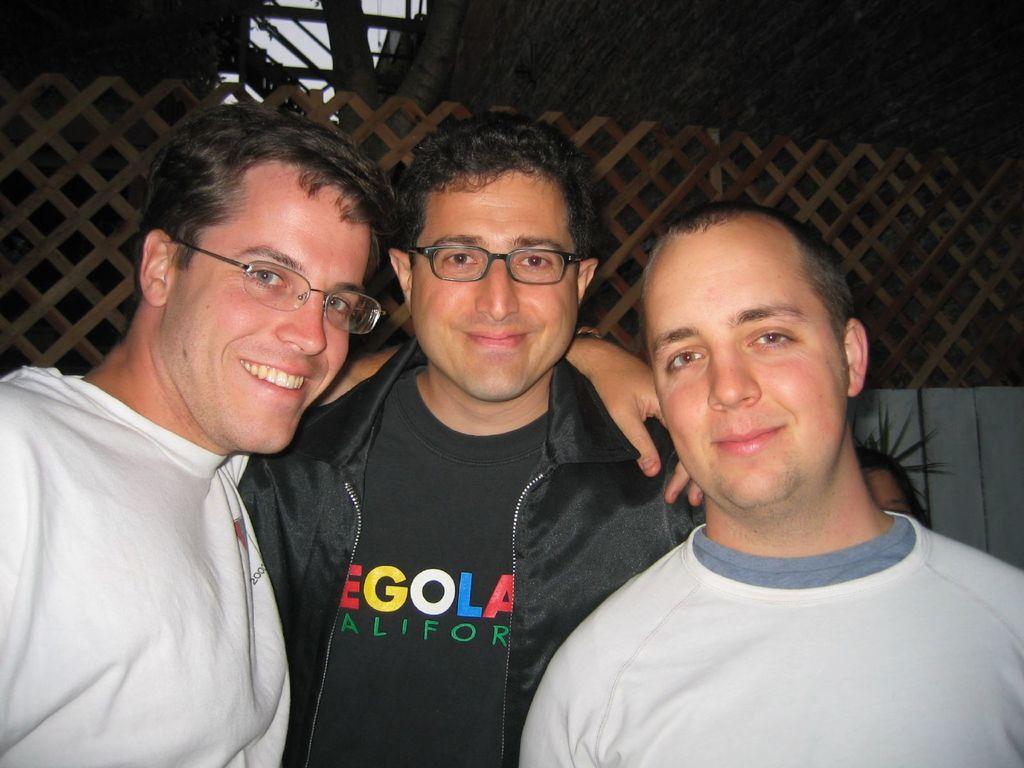How would you summarize this image in a sentence or two? There are three persons standing as we can see at the bottom of this image. The person standing in the middle is wearing black color t shirt and black color blazer. The person standing on the left side is wearing white color t shirt, and the person standing on the right side is also wearing a white color t shirt. There is a fencing in the background. 